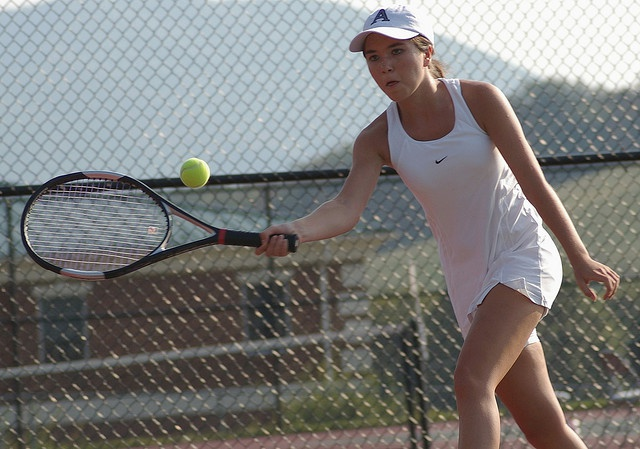Describe the objects in this image and their specific colors. I can see people in white, gray, maroon, and darkgray tones, tennis racket in white, gray, darkgray, and black tones, and sports ball in white and olive tones in this image. 